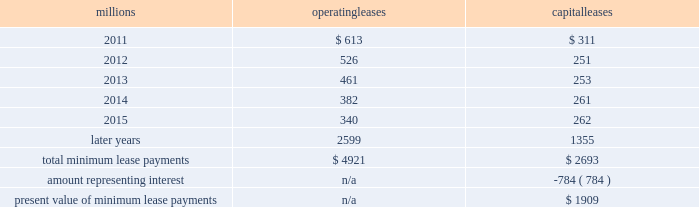2010 .
On november 1 , 2010 , we redeemed all $ 400 million of our outstanding 6.65% ( 6.65 % ) notes due january 15 , 2011 .
The redemption resulted in a $ 5 million early extinguishment charge .
Receivables securitization facility 2013 at december 31 , 2010 , we have recorded $ 100 million as secured debt under our receivables securitization facility .
( see further discussion of our receivables securitization facility in note 10. ) 15 .
Variable interest entities we have entered into various lease transactions in which the structure of the leases contain variable interest entities ( vies ) .
These vies were created solely for the purpose of doing lease transactions ( principally involving railroad equipment and facilities ) and have no other activities , assets or liabilities outside of the lease transactions .
Within these lease arrangements , we have the right to purchase some or all of the assets at fixed prices .
Depending on market conditions , fixed-price purchase options available in the leases could potentially provide benefits to us ; however , these benefits are not expected to be significant .
We maintain and operate the assets based on contractual obligations within the lease arrangements , which set specific guidelines consistent within the railroad industry .
As such , we have no control over activities that could materially impact the fair value of the leased assets .
We do not hold the power to direct the activities of the vies and , therefore , do not control the ongoing activities that have a significant impact on the economic performance of the vies .
Additionally , we do not have the obligation to absorb losses of the vies or the right to receive benefits of the vies that could potentially be significant to the we are not considered to be the primary beneficiary and do not consolidate these vies because our actions and decisions do not have the most significant effect on the vie 2019s performance and our fixed-price purchase price options are not considered to be potentially significant to the vie 2019s .
The future minimum lease payments associated with the vie leases totaled $ 4.2 billion as of december 31 , 2010 .
16 .
Leases we lease certain locomotives , freight cars , and other property .
The consolidated statement of financial position as of december 31 , 2010 and 2009 included $ 2520 million , net of $ 901 million of accumulated depreciation , and $ 2754 million , net of $ 927 million of accumulated depreciation , respectively , for properties held under capital leases .
A charge to income resulting from the depreciation for assets held under capital leases is included within depreciation expense in our consolidated statements of income .
Future minimum lease payments for operating and capital leases with initial or remaining non-cancelable lease terms in excess of one year as of december 31 , 2010 , were as follows : millions operating leases capital leases .
The majority of capital lease payments relate to locomotives .
Rent expense for operating leases with terms exceeding one month was $ 624 million in 2010 , $ 686 million in 2009 , and $ 747 million in 2008 .
When cash rental payments are not made on a straight-line basis , we recognize variable rental expense on a straight-line basis over the lease term .
Contingent rentals and sub-rentals are not significant. .
In 2010 what was the percent of the total minimum lease payments due in 2014? 
Computations: (526 / 4921)
Answer: 0.10689. 